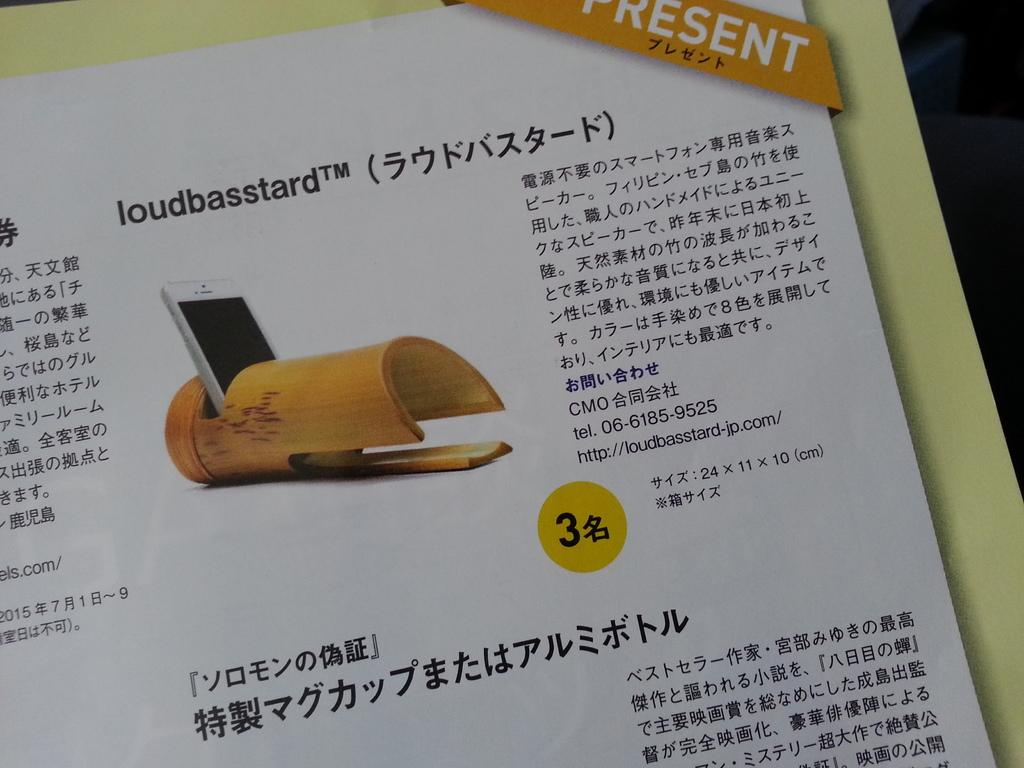Provide a one-sentence caption for the provided image. A Chinese poster with a  picture of a white phone  with the word present on top. 